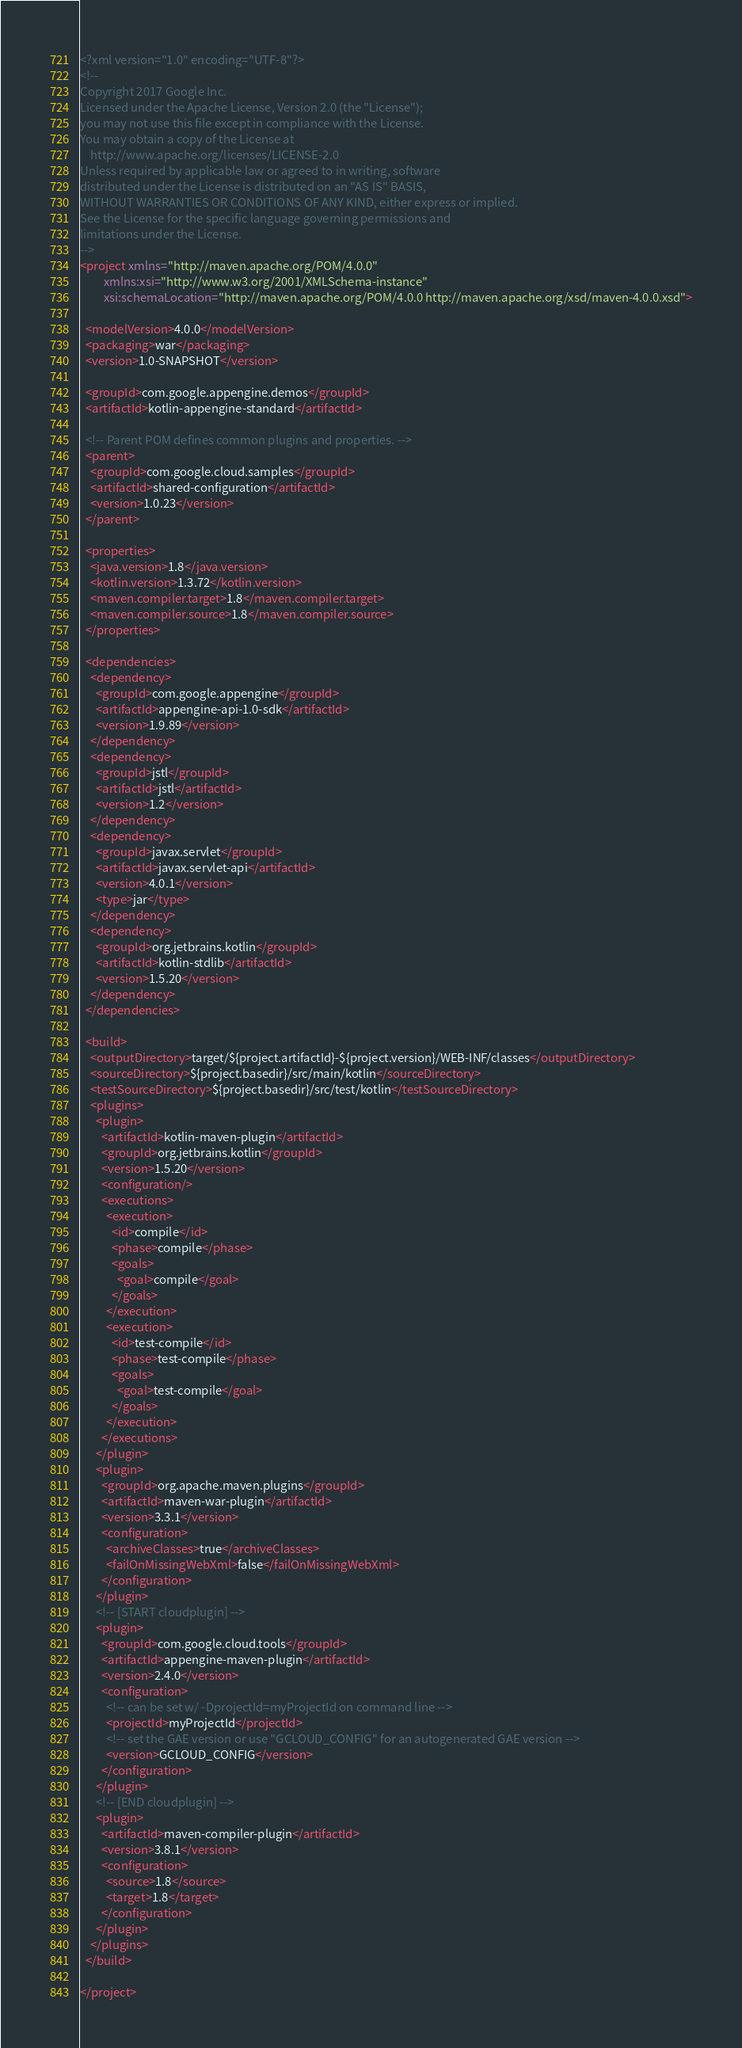<code> <loc_0><loc_0><loc_500><loc_500><_XML_><?xml version="1.0" encoding="UTF-8"?>
<!--
Copyright 2017 Google Inc.
Licensed under the Apache License, Version 2.0 (the "License");
you may not use this file except in compliance with the License.
You may obtain a copy of the License at
    http://www.apache.org/licenses/LICENSE-2.0
Unless required by applicable law or agreed to in writing, software
distributed under the License is distributed on an "AS IS" BASIS,
WITHOUT WARRANTIES OR CONDITIONS OF ANY KIND, either express or implied.
See the License for the specific language governing permissions and
limitations under the License.
-->
<project xmlns="http://maven.apache.org/POM/4.0.0"
         xmlns:xsi="http://www.w3.org/2001/XMLSchema-instance"
         xsi:schemaLocation="http://maven.apache.org/POM/4.0.0 http://maven.apache.org/xsd/maven-4.0.0.xsd">

  <modelVersion>4.0.0</modelVersion>
  <packaging>war</packaging>
  <version>1.0-SNAPSHOT</version>

  <groupId>com.google.appengine.demos</groupId>
  <artifactId>kotlin-appengine-standard</artifactId>

  <!-- Parent POM defines common plugins and properties. -->
  <parent>
    <groupId>com.google.cloud.samples</groupId>
    <artifactId>shared-configuration</artifactId>
    <version>1.0.23</version>
  </parent>

  <properties>
    <java.version>1.8</java.version>
    <kotlin.version>1.3.72</kotlin.version>
    <maven.compiler.target>1.8</maven.compiler.target>
    <maven.compiler.source>1.8</maven.compiler.source>
  </properties>

  <dependencies>
    <dependency>
      <groupId>com.google.appengine</groupId>
      <artifactId>appengine-api-1.0-sdk</artifactId>
      <version>1.9.89</version>
    </dependency>
    <dependency>
      <groupId>jstl</groupId>
      <artifactId>jstl</artifactId>
      <version>1.2</version>
    </dependency>
    <dependency>
      <groupId>javax.servlet</groupId>
      <artifactId>javax.servlet-api</artifactId>
      <version>4.0.1</version>
      <type>jar</type>
    </dependency>
    <dependency>
      <groupId>org.jetbrains.kotlin</groupId>
      <artifactId>kotlin-stdlib</artifactId>
      <version>1.5.20</version>
    </dependency>
  </dependencies>

  <build>
    <outputDirectory>target/${project.artifactId}-${project.version}/WEB-INF/classes</outputDirectory>
    <sourceDirectory>${project.basedir}/src/main/kotlin</sourceDirectory>
    <testSourceDirectory>${project.basedir}/src/test/kotlin</testSourceDirectory>
    <plugins>
      <plugin>
        <artifactId>kotlin-maven-plugin</artifactId>
        <groupId>org.jetbrains.kotlin</groupId>
        <version>1.5.20</version>
        <configuration/>
        <executions>
          <execution>
            <id>compile</id>
            <phase>compile</phase>
            <goals>
              <goal>compile</goal>
            </goals>
          </execution>
          <execution>
            <id>test-compile</id>
            <phase>test-compile</phase>
            <goals>
              <goal>test-compile</goal>
            </goals>
          </execution>
        </executions>
      </plugin>
      <plugin>
        <groupId>org.apache.maven.plugins</groupId>
        <artifactId>maven-war-plugin</artifactId>
        <version>3.3.1</version>
        <configuration>
          <archiveClasses>true</archiveClasses>
          <failOnMissingWebXml>false</failOnMissingWebXml>
        </configuration>
      </plugin>
      <!-- [START cloudplugin] -->
      <plugin>
        <groupId>com.google.cloud.tools</groupId>
        <artifactId>appengine-maven-plugin</artifactId>
        <version>2.4.0</version>
        <configuration>
          <!-- can be set w/ -DprojectId=myProjectId on command line -->
          <projectId>myProjectId</projectId>
          <!-- set the GAE version or use "GCLOUD_CONFIG" for an autogenerated GAE version -->
          <version>GCLOUD_CONFIG</version>
        </configuration>
      </plugin>
      <!-- [END cloudplugin] -->
      <plugin>
        <artifactId>maven-compiler-plugin</artifactId>
        <version>3.8.1</version>
        <configuration>
          <source>1.8</source>
          <target>1.8</target>
        </configuration>
      </plugin>
    </plugins>
  </build>

</project>
</code> 